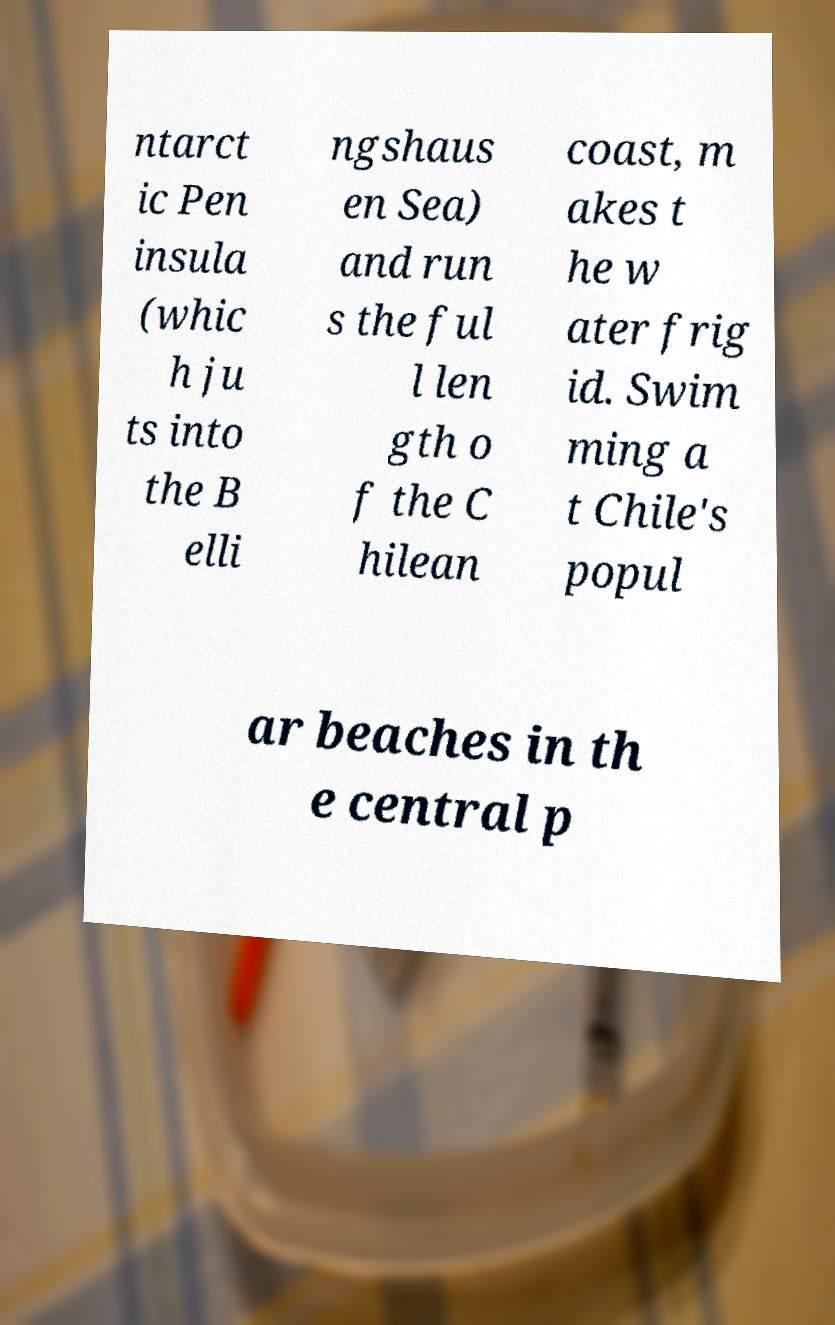For documentation purposes, I need the text within this image transcribed. Could you provide that? ntarct ic Pen insula (whic h ju ts into the B elli ngshaus en Sea) and run s the ful l len gth o f the C hilean coast, m akes t he w ater frig id. Swim ming a t Chile's popul ar beaches in th e central p 